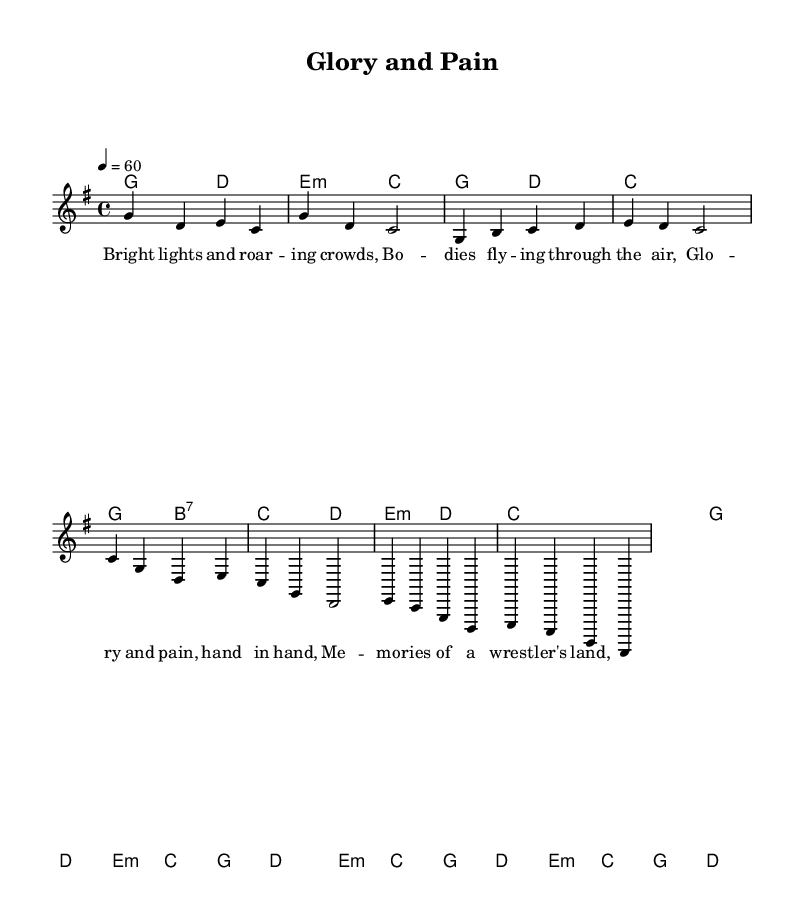What is the key signature of this music? The key signature, indicated at the beginning of the score, shows that there are no sharps or flats, which corresponds to the key of G major.
Answer: G major What is the time signature of this music? The time signature, found at the beginning of the score, is 4/4, which means there are four beats in each measure and a quarter note receives one beat.
Answer: 4/4 What is the tempo marking of this music? The tempo marking is indicated in the score as "4 = 60," meaning there are 60 beats per minute, typically indicating a slow and steady pace.
Answer: 60 How many measures are there in the introductory section? By counting the measures in the introductory section as indicated in the music, there are four measures before the verse starts.
Answer: 4 What are the primary themes represented in the lyrics? The primary themes in the lyrics reflect nostalgia for a wrestling career combined with the physical toll it takes, as expressed through phrases like "bright lights" and "glory and pain."
Answer: Nostalgia and pain Is the melody consistent with traditional Country Rock elements? The melody utilizes typical Country Rock elements, including the use of simple chord progressions and a strong lyrical narrative, which enhances emotional resonance, a hallmark of the genre.
Answer: Yes 